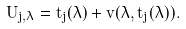<formula> <loc_0><loc_0><loc_500><loc_500>U _ { j , \lambda } = t _ { j } ( \lambda ) + v ( \lambda , t _ { j } ( \lambda ) ) .</formula> 